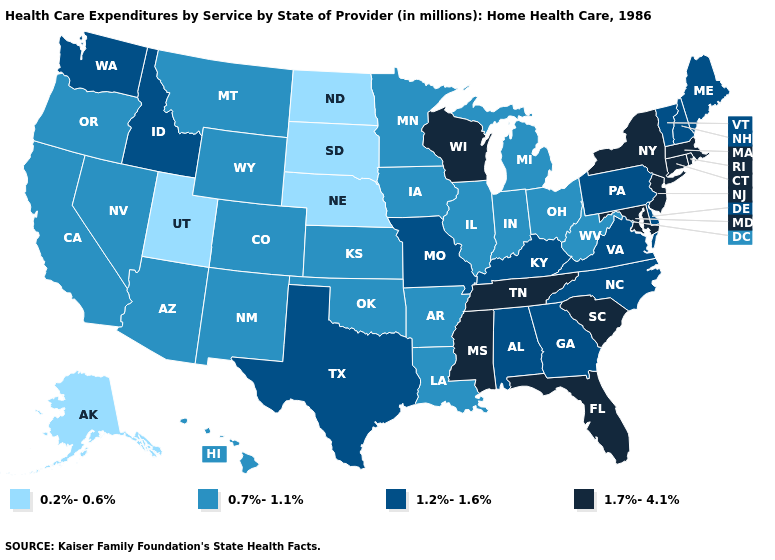What is the value of Oklahoma?
Give a very brief answer. 0.7%-1.1%. Name the states that have a value in the range 0.7%-1.1%?
Write a very short answer. Arizona, Arkansas, California, Colorado, Hawaii, Illinois, Indiana, Iowa, Kansas, Louisiana, Michigan, Minnesota, Montana, Nevada, New Mexico, Ohio, Oklahoma, Oregon, West Virginia, Wyoming. Name the states that have a value in the range 1.7%-4.1%?
Be succinct. Connecticut, Florida, Maryland, Massachusetts, Mississippi, New Jersey, New York, Rhode Island, South Carolina, Tennessee, Wisconsin. Does New Jersey have the highest value in the USA?
Short answer required. Yes. Name the states that have a value in the range 0.2%-0.6%?
Keep it brief. Alaska, Nebraska, North Dakota, South Dakota, Utah. Does the first symbol in the legend represent the smallest category?
Keep it brief. Yes. Which states hav the highest value in the Northeast?
Concise answer only. Connecticut, Massachusetts, New Jersey, New York, Rhode Island. Among the states that border Kentucky , which have the highest value?
Be succinct. Tennessee. Does Texas have the lowest value in the USA?
Quick response, please. No. Does New Mexico have the highest value in the USA?
Short answer required. No. Name the states that have a value in the range 1.7%-4.1%?
Quick response, please. Connecticut, Florida, Maryland, Massachusetts, Mississippi, New Jersey, New York, Rhode Island, South Carolina, Tennessee, Wisconsin. Does Missouri have a lower value than New York?
Keep it brief. Yes. Is the legend a continuous bar?
Keep it brief. No. Does South Dakota have the lowest value in the USA?
Concise answer only. Yes. Is the legend a continuous bar?
Quick response, please. No. 